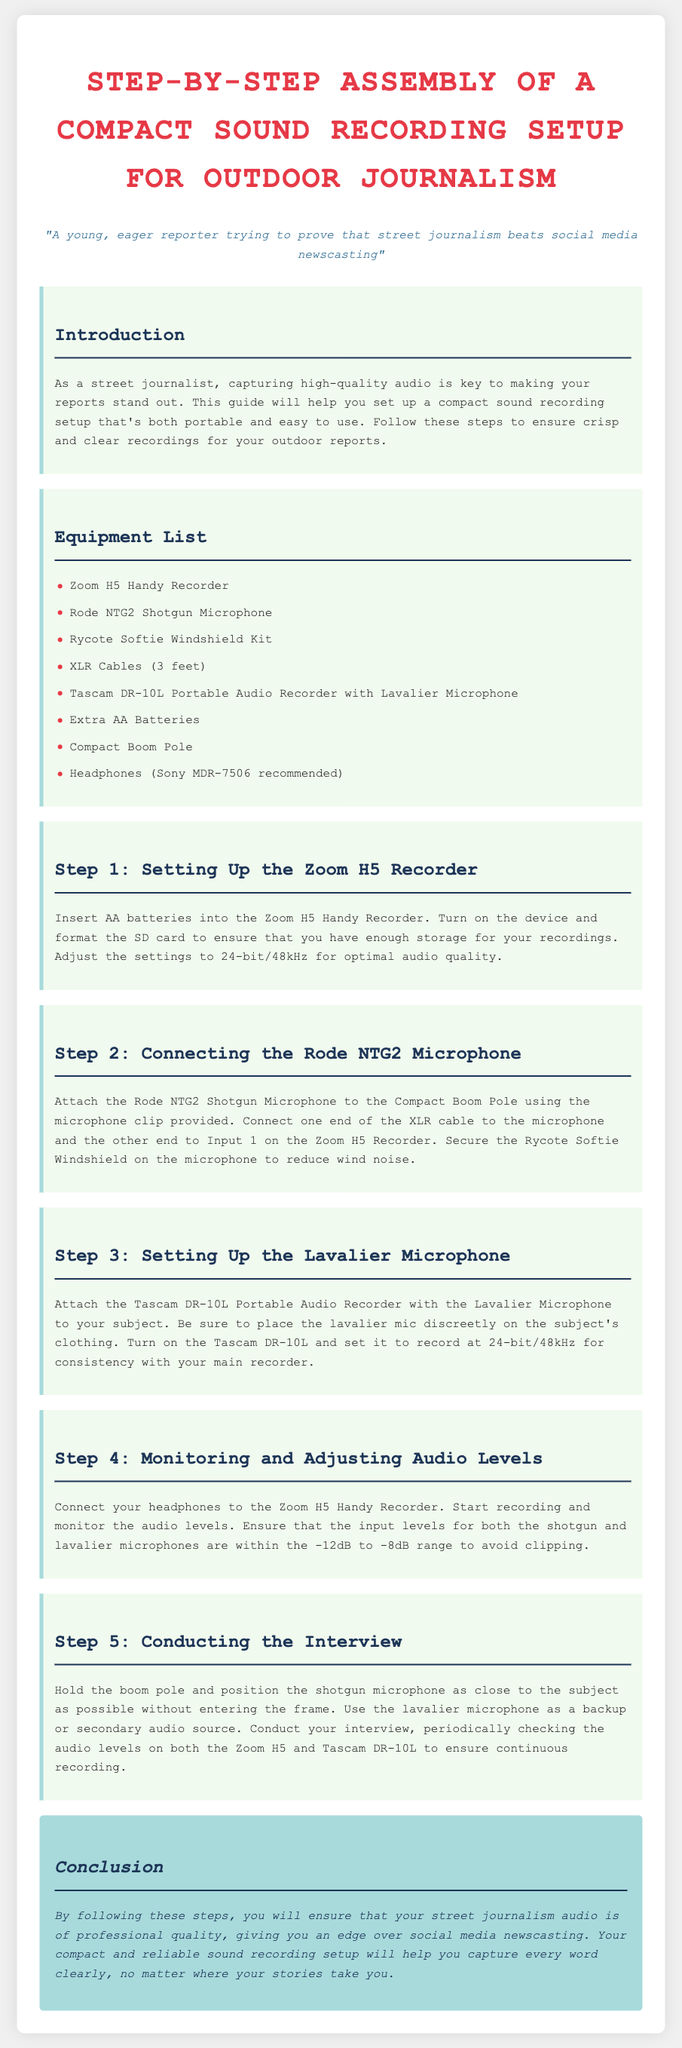What equipment is included in the setup? The document lists several pieces of equipment required for the sound recording setup, including the Zoom H5 Handy Recorder, Rode NTG2 Shotgun Microphone, and others.
Answer: Zoom H5 Handy Recorder, Rode NTG2 Shotgun Microphone, Rycote Softie Windshield Kit, XLR Cables, Tascam DR-10L, Extra AA Batteries, Compact Boom Pole, Headphones What audio quality setting is recommended for the Zoom H5? The instructions specify the optimal settings for audio quality when using the Zoom H5 Handy Recorder.
Answer: 24-bit/48kHz What is the purpose of the Rycote Softie Windshield? The document explains that the Rycote Softie Windshield is used to reduce wind noise when recording outdoor audio.
Answer: To reduce wind noise How do you monitor audio levels during recording? The instructions indicate to connect headphones to the Zoom H5 Handy Recorder to monitor audio levels while recording.
Answer: Connect headphones What should be checked periodically during the interview? The document advises checking audio levels on both recording devices regularly to ensure continuous recording quality.
Answer: Audio levels 